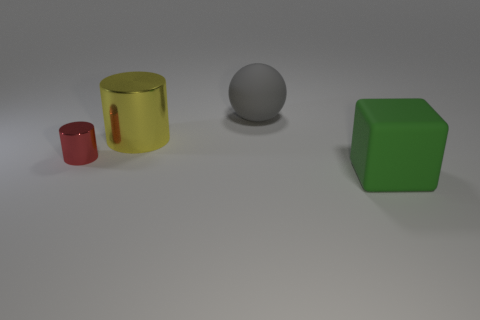Add 2 big matte cubes. How many objects exist? 6 Subtract all blue blocks. Subtract all brown cylinders. How many blocks are left? 1 Subtract all large shiny things. Subtract all large blocks. How many objects are left? 2 Add 3 metallic cylinders. How many metallic cylinders are left? 5 Add 2 large blocks. How many large blocks exist? 3 Subtract 0 blue cubes. How many objects are left? 4 